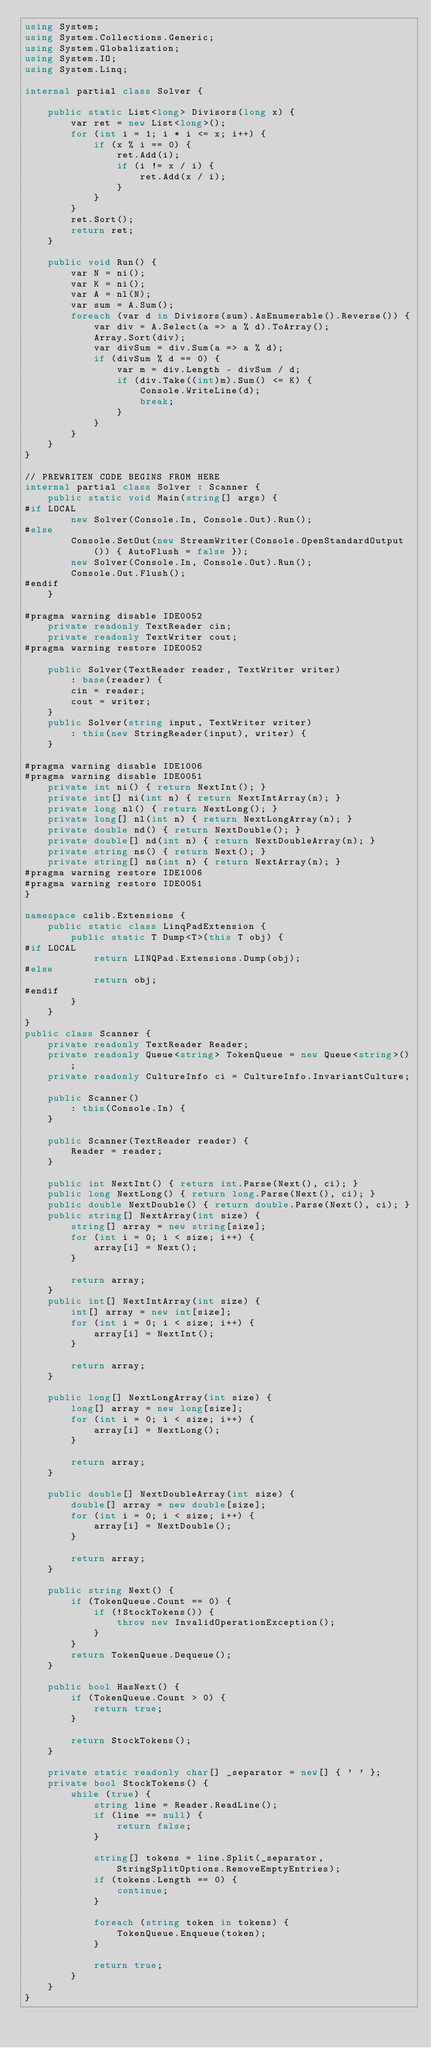Convert code to text. <code><loc_0><loc_0><loc_500><loc_500><_C#_>using System;
using System.Collections.Generic;
using System.Globalization;
using System.IO;
using System.Linq;

internal partial class Solver {

    public static List<long> Divisors(long x) {
        var ret = new List<long>();
        for (int i = 1; i * i <= x; i++) {
            if (x % i == 0) {
                ret.Add(i);
                if (i != x / i) {
                    ret.Add(x / i);
                }
            }
        }
        ret.Sort();
        return ret;
    }

    public void Run() {
        var N = ni();
        var K = ni();
        var A = nl(N);
        var sum = A.Sum();
        foreach (var d in Divisors(sum).AsEnumerable().Reverse()) {
            var div = A.Select(a => a % d).ToArray();
            Array.Sort(div);
            var divSum = div.Sum(a => a % d);
            if (divSum % d == 0) {
                var m = div.Length - divSum / d;
                if (div.Take((int)m).Sum() <= K) {
                    Console.WriteLine(d);
                    break;
                }
            }
        }
    }
}

// PREWRITEN CODE BEGINS FROM HERE
internal partial class Solver : Scanner {
    public static void Main(string[] args) {
#if LOCAL
        new Solver(Console.In, Console.Out).Run();
#else
        Console.SetOut(new StreamWriter(Console.OpenStandardOutput()) { AutoFlush = false });
        new Solver(Console.In, Console.Out).Run();
        Console.Out.Flush();
#endif
    }

#pragma warning disable IDE0052
    private readonly TextReader cin;
    private readonly TextWriter cout;
#pragma warning restore IDE0052

    public Solver(TextReader reader, TextWriter writer)
        : base(reader) {
        cin = reader;
        cout = writer;
    }
    public Solver(string input, TextWriter writer)
        : this(new StringReader(input), writer) {
    }

#pragma warning disable IDE1006
#pragma warning disable IDE0051
    private int ni() { return NextInt(); }
    private int[] ni(int n) { return NextIntArray(n); }
    private long nl() { return NextLong(); }
    private long[] nl(int n) { return NextLongArray(n); }
    private double nd() { return NextDouble(); }
    private double[] nd(int n) { return NextDoubleArray(n); }
    private string ns() { return Next(); }
    private string[] ns(int n) { return NextArray(n); }
#pragma warning restore IDE1006
#pragma warning restore IDE0051
}

namespace cslib.Extensions {
    public static class LinqPadExtension {
        public static T Dump<T>(this T obj) {
#if LOCAL
            return LINQPad.Extensions.Dump(obj);
#else
            return obj;
#endif
        }
    }
}
public class Scanner {
    private readonly TextReader Reader;
    private readonly Queue<string> TokenQueue = new Queue<string>();
    private readonly CultureInfo ci = CultureInfo.InvariantCulture;

    public Scanner()
        : this(Console.In) {
    }

    public Scanner(TextReader reader) {
        Reader = reader;
    }

    public int NextInt() { return int.Parse(Next(), ci); }
    public long NextLong() { return long.Parse(Next(), ci); }
    public double NextDouble() { return double.Parse(Next(), ci); }
    public string[] NextArray(int size) {
        string[] array = new string[size];
        for (int i = 0; i < size; i++) {
            array[i] = Next();
        }

        return array;
    }
    public int[] NextIntArray(int size) {
        int[] array = new int[size];
        for (int i = 0; i < size; i++) {
            array[i] = NextInt();
        }

        return array;
    }

    public long[] NextLongArray(int size) {
        long[] array = new long[size];
        for (int i = 0; i < size; i++) {
            array[i] = NextLong();
        }

        return array;
    }

    public double[] NextDoubleArray(int size) {
        double[] array = new double[size];
        for (int i = 0; i < size; i++) {
            array[i] = NextDouble();
        }

        return array;
    }

    public string Next() {
        if (TokenQueue.Count == 0) {
            if (!StockTokens()) {
                throw new InvalidOperationException();
            }
        }
        return TokenQueue.Dequeue();
    }

    public bool HasNext() {
        if (TokenQueue.Count > 0) {
            return true;
        }

        return StockTokens();
    }

    private static readonly char[] _separator = new[] { ' ' };
    private bool StockTokens() {
        while (true) {
            string line = Reader.ReadLine();
            if (line == null) {
                return false;
            }

            string[] tokens = line.Split(_separator, StringSplitOptions.RemoveEmptyEntries);
            if (tokens.Length == 0) {
                continue;
            }

            foreach (string token in tokens) {
                TokenQueue.Enqueue(token);
            }

            return true;
        }
    }
}
</code> 